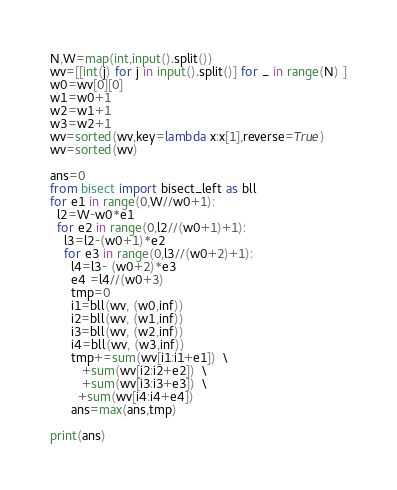<code> <loc_0><loc_0><loc_500><loc_500><_Python_>N,W=map(int,input().split())
wv=[[int(j) for j in input().split()] for _ in range(N) ]
w0=wv[0][0]
w1=w0+1
w2=w1+1 
w3=w2+1
wv=sorted(wv,key=lambda x:x[1],reverse=True)
wv=sorted(wv)

ans=0
from bisect import bisect_left as bll
for e1 in range(0,W//w0+1):
  l2=W-w0*e1
  for e2 in range(0,l2//(w0+1)+1):
    l3=l2-(w0+1)*e2
    for e3 in range(0,l3//(w0+2)+1):
      l4=l3- (w0+2)*e3
      e4 =l4//(w0+3)    
      tmp=0
      i1=bll(wv, (w0,inf))
      i2=bll(wv, (w1,inf))
      i3=bll(wv, (w2,inf))
      i4=bll(wv, (w3,inf))
      tmp+=sum(wv[i1:i1+e1])  \
         +sum(wv[i2:i2+e2])  \
         +sum(wv[i3:i3+e3])  \
        +sum(wv[i4:i4+e4])
      ans=max(ans,tmp)
      
print(ans)</code> 